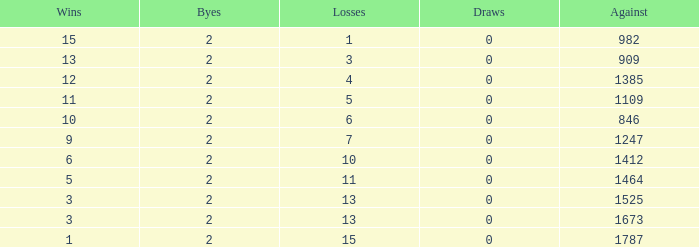What is the highest number listed under against when there were less than 3 wins and less than 15 losses? None. 